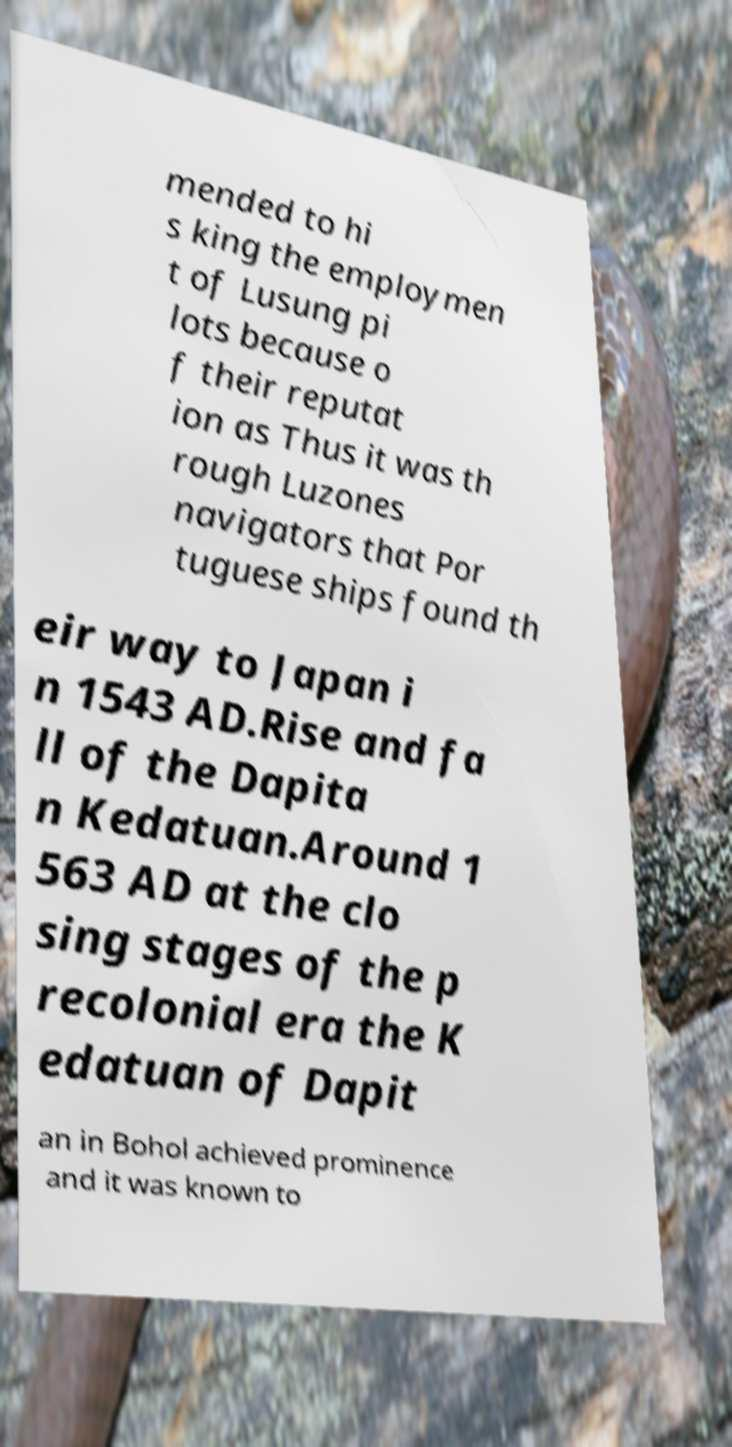What messages or text are displayed in this image? I need them in a readable, typed format. mended to hi s king the employmen t of Lusung pi lots because o f their reputat ion as Thus it was th rough Luzones navigators that Por tuguese ships found th eir way to Japan i n 1543 AD.Rise and fa ll of the Dapita n Kedatuan.Around 1 563 AD at the clo sing stages of the p recolonial era the K edatuan of Dapit an in Bohol achieved prominence and it was known to 